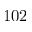Convert formula to latex. <formula><loc_0><loc_0><loc_500><loc_500>1 0 2</formula> 